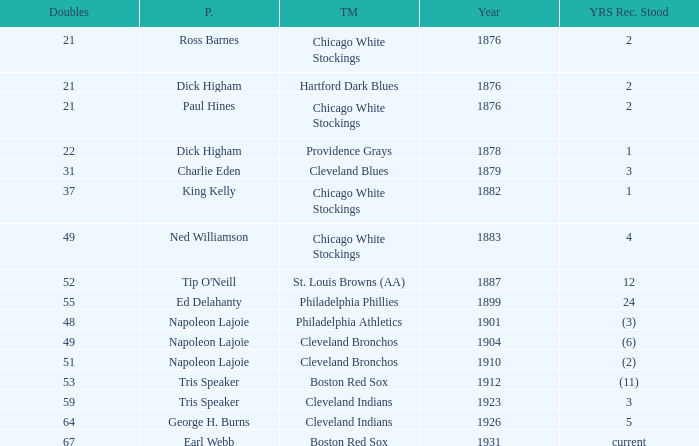Player of napoleon lajoie, and a Team of cleveland bronchos, and a Doubles of 49 which years record stood? (6). 